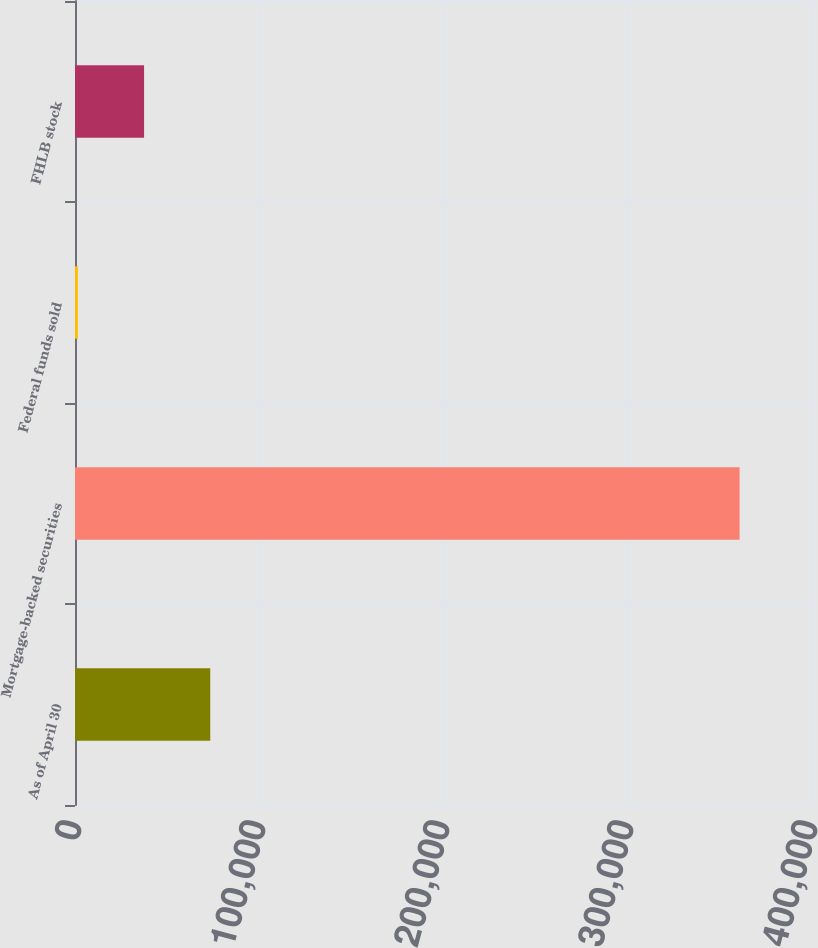<chart> <loc_0><loc_0><loc_500><loc_500><bar_chart><fcel>As of April 30<fcel>Mortgage-backed securities<fcel>Federal funds sold<fcel>FHLB stock<nl><fcel>73505.6<fcel>361184<fcel>1586<fcel>37545.8<nl></chart> 